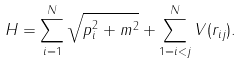Convert formula to latex. <formula><loc_0><loc_0><loc_500><loc_500>H = \sum _ { i = 1 } ^ { N } \sqrt { { p } _ { i } ^ { 2 } + m ^ { 2 } } + \sum _ { 1 = i < j } ^ { N } V ( r _ { i j } ) .</formula> 